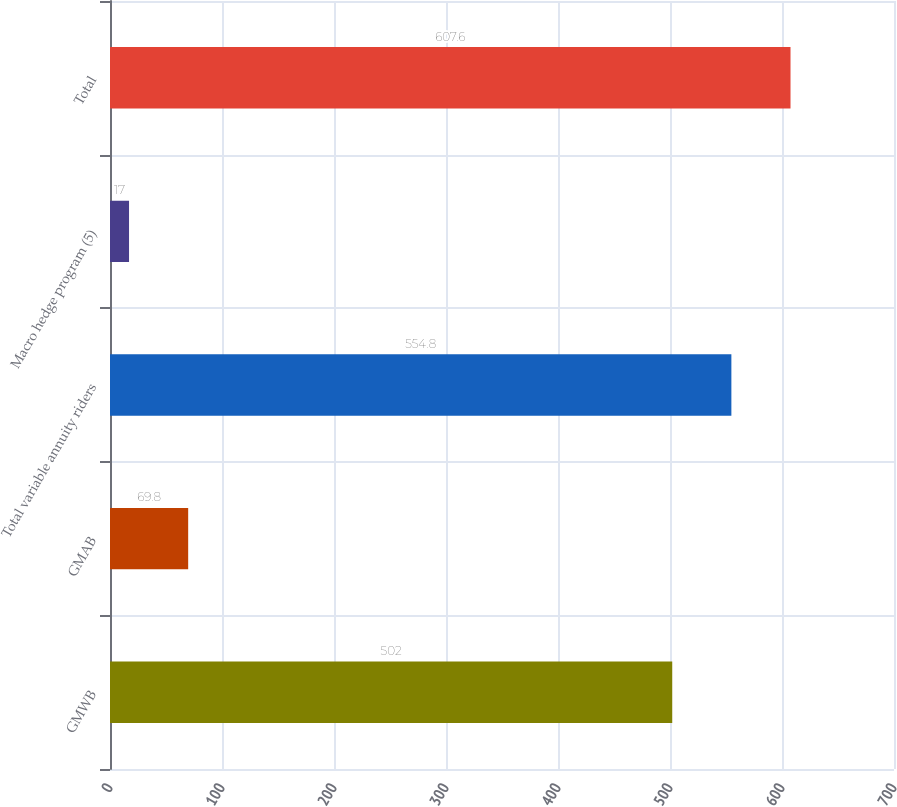Convert chart to OTSL. <chart><loc_0><loc_0><loc_500><loc_500><bar_chart><fcel>GMWB<fcel>GMAB<fcel>Total variable annuity riders<fcel>Macro hedge program (5)<fcel>Total<nl><fcel>502<fcel>69.8<fcel>554.8<fcel>17<fcel>607.6<nl></chart> 